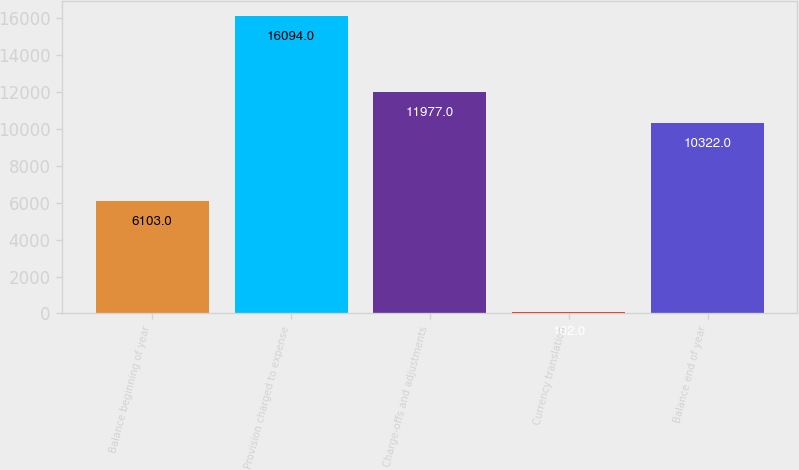<chart> <loc_0><loc_0><loc_500><loc_500><bar_chart><fcel>Balance beginning of year<fcel>Provision charged to expense<fcel>Charge-offs and adjustments<fcel>Currency translation<fcel>Balance end of year<nl><fcel>6103<fcel>16094<fcel>11977<fcel>102<fcel>10322<nl></chart> 